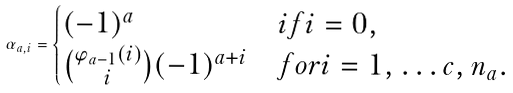<formula> <loc_0><loc_0><loc_500><loc_500>\alpha _ { a , i } = \begin{cases} ( - 1 ) ^ { a } & i f i = 0 , \\ \binom { \varphi _ { a - 1 } ( i ) } { i } ( - 1 ) ^ { a + i } & f o r i = 1 , \dots c , n _ { a } . \end{cases}</formula> 